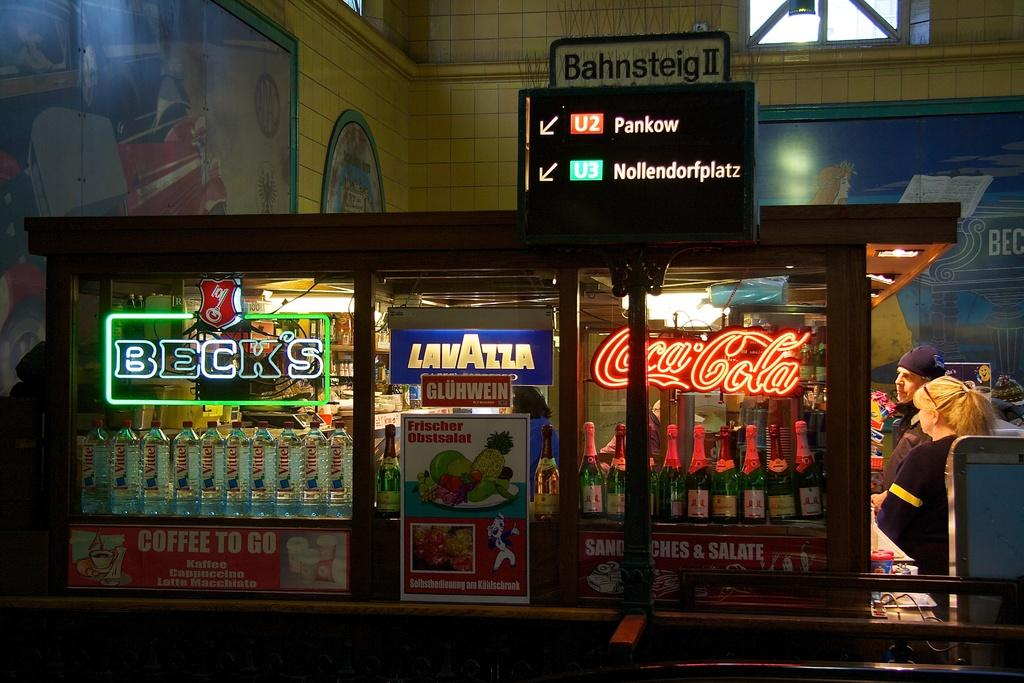What objects can be seen in the image that are used for holding liquids? There are bottles in the image that are used for holding liquids. What objects in the image are used for displaying information or advertising? There are banners and a direction board in the image that are used for displaying information or advertising. What type of decorative items are present on the wall in the image? There is a wall with frames in the image. What architectural feature is visible in the image that allows light and air to enter the space? There are windows in the image that allow light and air to enter the space. How many people are present in the image? There are two persons in the image. Can you tell me what type of instrument the toad is playing in the image? There is no toad or instrument present in the image. How many worms can be seen crawling on the banners in the image? There are no worms present in the image. 